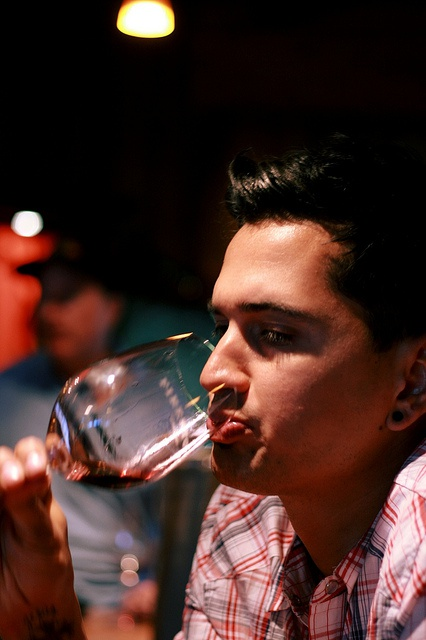Describe the objects in this image and their specific colors. I can see people in black, maroon, lightpink, and brown tones, people in black, gray, maroon, and brown tones, and wine glass in black, gray, brown, and maroon tones in this image. 